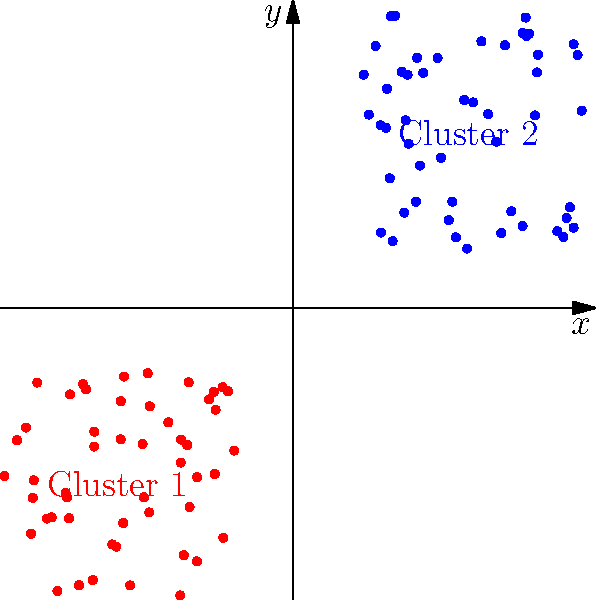Based on the 2D scatter plot shown, which clustering algorithm would be most appropriate for separating the two distinct clusters, and why? To determine the most appropriate clustering algorithm for this dataset, we need to analyze the characteristics of the scatter plot:

1. Visual inspection: The plot shows two distinct, well-separated clusters with roughly circular shapes.

2. Cluster properties:
   a. The clusters appear to have similar sizes (approximately 50 points each).
   b. The clusters have similar densities.
   c. The clusters are linearly separable.
   d. The clusters do not have complex shapes or varying densities.

3. Clustering algorithm considerations:
   a. K-means: Suitable for spherical clusters of similar size and density.
   b. DBSCAN: Better for clusters with varying densities and shapes.
   c. Hierarchical clustering: Can handle various cluster shapes but may be computationally expensive.
   d. Gaussian Mixture Models (GMM): Effective for overlapping, elliptical clusters.

4. Best choice: K-means clustering
   Reasons:
   - The clusters are well-separated and roughly spherical.
   - The clusters have similar sizes and densities.
   - K-means is computationally efficient and works well for this type of data.
   - The number of clusters (K=2) is clearly visible and can be easily specified.

5. Alternative: Gaussian Mixture Models (GMM) could also work well, but may be unnecessarily complex for this simple dataset.

In conclusion, K-means clustering would be the most appropriate algorithm for this dataset due to its simplicity, efficiency, and suitability for the observed cluster characteristics.
Answer: K-means clustering 